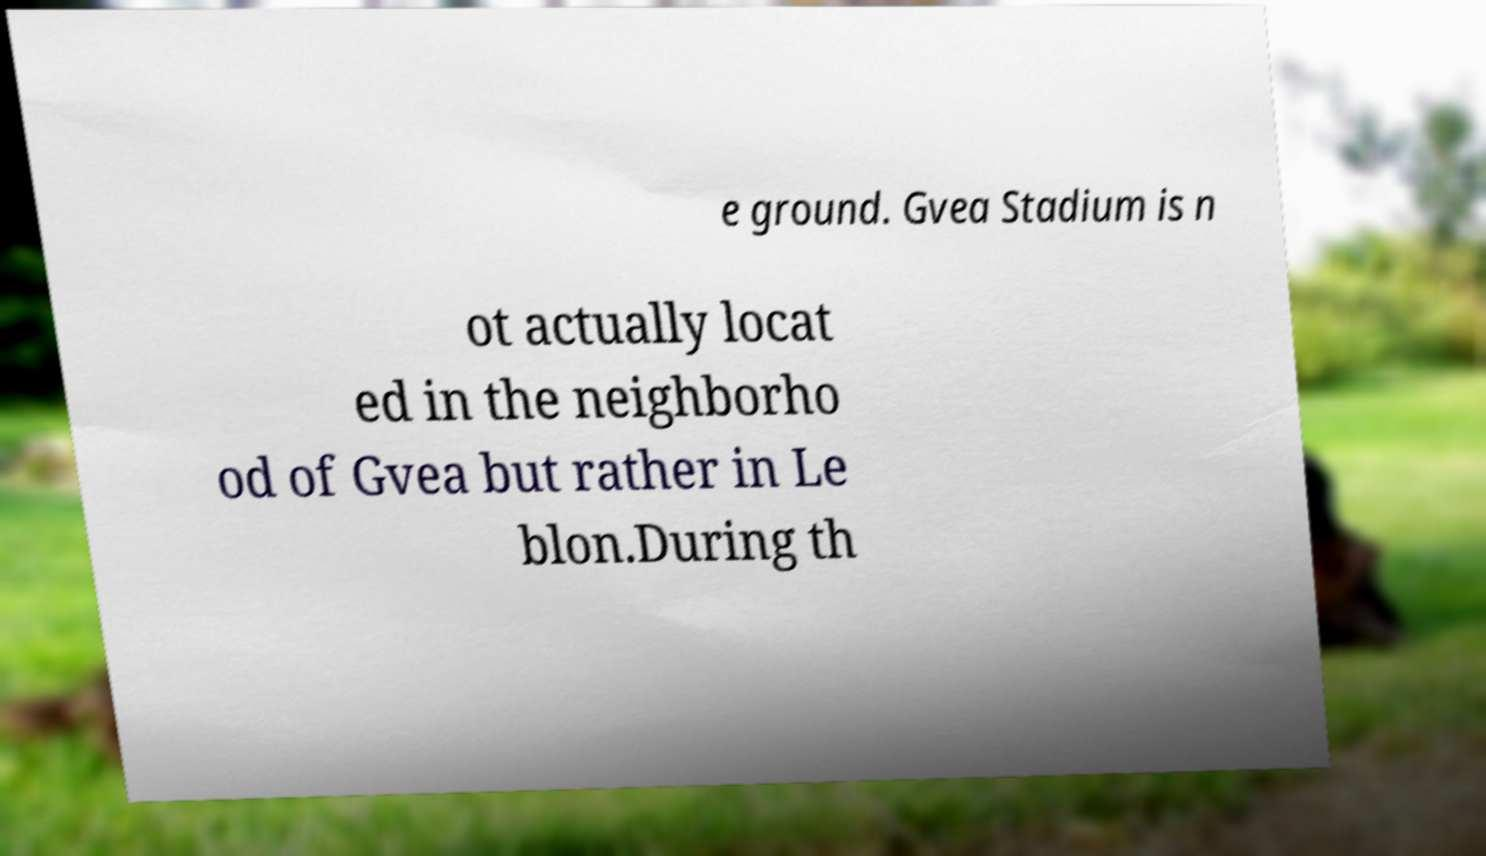Can you read and provide the text displayed in the image?This photo seems to have some interesting text. Can you extract and type it out for me? e ground. Gvea Stadium is n ot actually locat ed in the neighborho od of Gvea but rather in Le blon.During th 